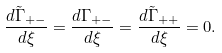<formula> <loc_0><loc_0><loc_500><loc_500>\frac { d \tilde { \Gamma } _ { + - } } { d \xi } = \frac { d \Gamma _ { + - } } { d \xi } = \frac { d \tilde { \Gamma } _ { + + } } { d \xi } = 0 .</formula> 